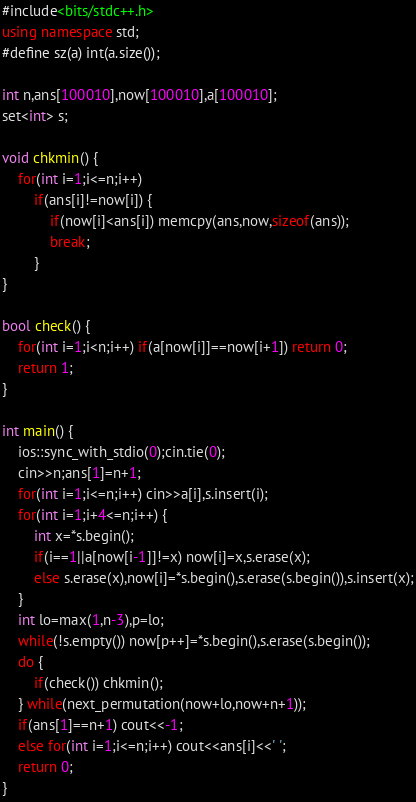Convert code to text. <code><loc_0><loc_0><loc_500><loc_500><_C++_>#include<bits/stdc++.h>
using namespace std;
#define sz(a) int(a.size());

int n,ans[100010],now[100010],a[100010];
set<int> s;

void chkmin() {
	for(int i=1;i<=n;i++)
		if(ans[i]!=now[i]) {
			if(now[i]<ans[i]) memcpy(ans,now,sizeof(ans));
			break;
		}
}

bool check() {
	for(int i=1;i<n;i++) if(a[now[i]]==now[i+1]) return 0;
	return 1;
}

int main() {
	ios::sync_with_stdio(0);cin.tie(0);
	cin>>n;ans[1]=n+1;
	for(int i=1;i<=n;i++) cin>>a[i],s.insert(i);
	for(int i=1;i+4<=n;i++) {
		int x=*s.begin();
		if(i==1||a[now[i-1]]!=x) now[i]=x,s.erase(x);
		else s.erase(x),now[i]=*s.begin(),s.erase(s.begin()),s.insert(x);
	}
	int lo=max(1,n-3),p=lo;
	while(!s.empty()) now[p++]=*s.begin(),s.erase(s.begin());
	do {
		if(check()) chkmin();
	} while(next_permutation(now+lo,now+n+1));
	if(ans[1]==n+1) cout<<-1;
	else for(int i=1;i<=n;i++) cout<<ans[i]<<' ';
	return 0;
}
</code> 